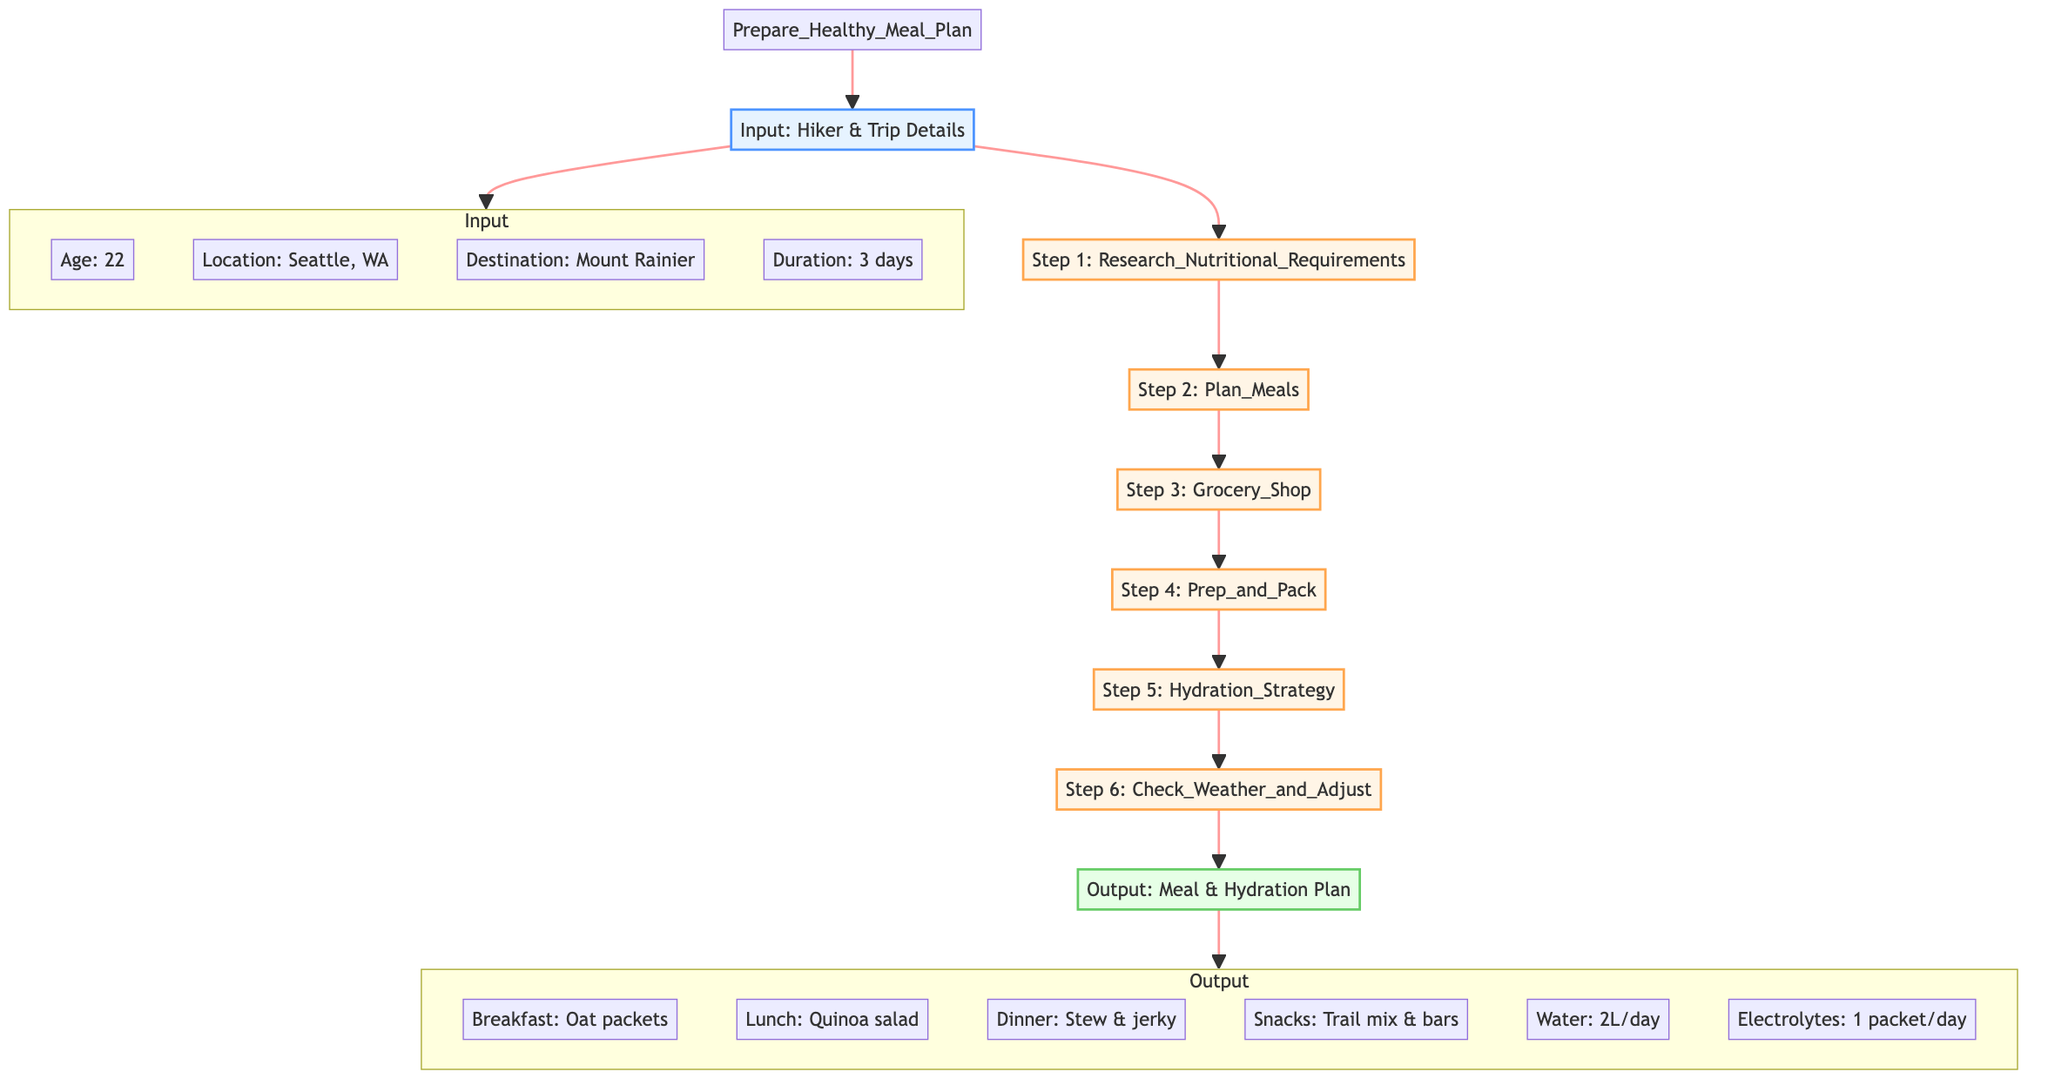What is the first step in the meal planning process? The first step in the flowchart is labeled "Step 1: Research_Nutritional_Requirements." This node is connected directly to the input node and is the first action listed in the sequence of steps.
Answer: Research Nutritional Requirements How many total steps are involved in preparing the healthy meal plan? The flowchart outlines a total of six steps from "Research Nutritional Requirements" to "Check Weather and Adjust." The steps are sequentially connected.
Answer: 6 What is the output of the meal plan for breakfast? The output node includes various meal options, and under breakfast, it specifies "Oat packets with nuts and dried fruits," which is the designated breakfast for the meal plan.
Answer: Oat packets with nuts and dried fruits How does hydration planning fit into the meal planning process? Hydration Strategy is the fifth step in the sequence, following meal preparation and grocery shopping, indicating that it is a crucial part of the overall planning, specifically focused on hydration needs after meal prep.
Answer: Fifth step What are the two components listed in the hydration plan? The hydration plan has two specific components detailed in the output section: "Water: 2 liters per day" and "Electrolytes: 1 packet per day," enumerating the required hydration intake.
Answer: Water and electrolytes If the weather at Mount Rainier changes, which step would you need to revisit? The "Check Weather and Adjust" step is specifically focused on ensuring that plans can adapt based on weather forecasts, making it the step to revisit if there's a change in the weather.
Answer: Check Weather and Adjust What ingredients are specified for shopping in step three? The grocery shopping step lists specific ingredients: oats, nuts, dried fruits, quinoa, trail mix, jerky, fresh vegetables, and hydration supplements, ensuring a comprehensive shopping list.
Answer: Oats, nuts, dried fruits, quinoa, trail mix, jerky, fresh vegetables, hydration supplements What location is specified for the hiking adventure? The input section of the flowchart clearly indicates "Mount Rainier National Park" as the destination for the hiking and meal planning.
Answer: Mount Rainier National Park 